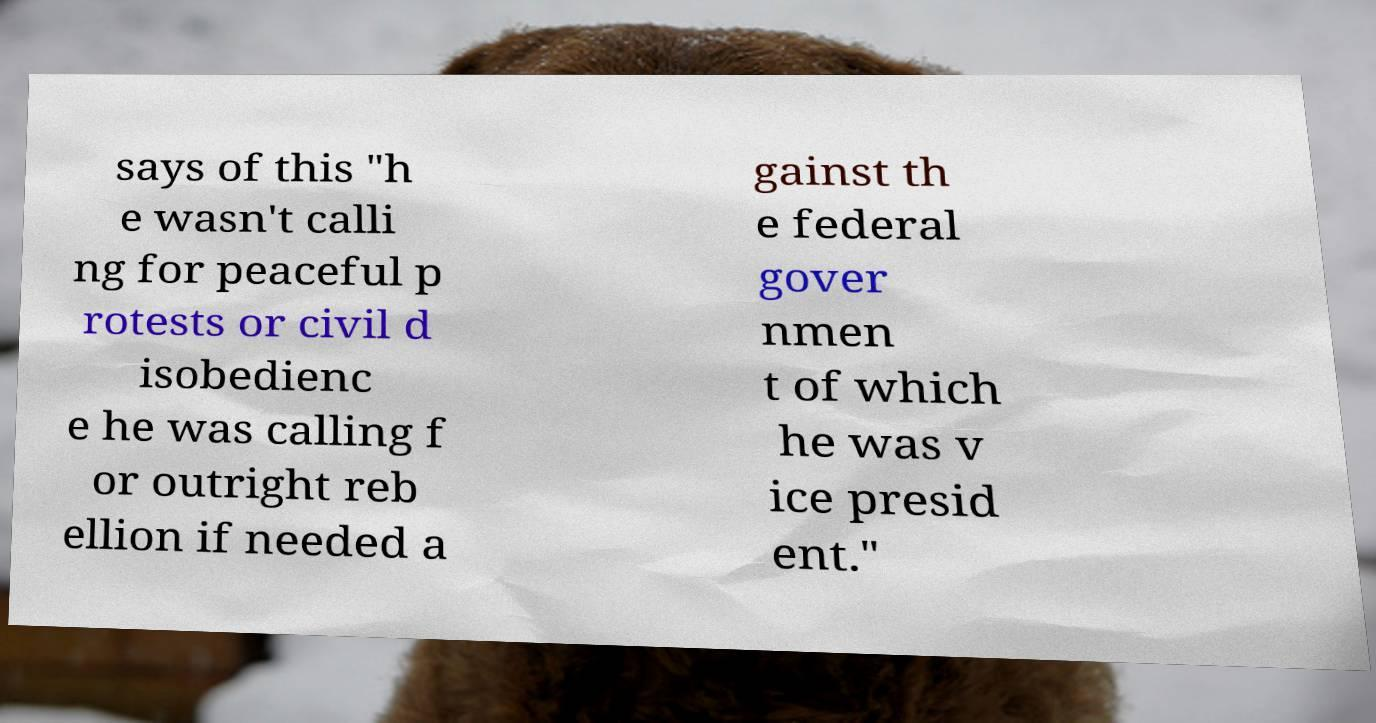I need the written content from this picture converted into text. Can you do that? says of this "h e wasn't calli ng for peaceful p rotests or civil d isobedienc e he was calling f or outright reb ellion if needed a gainst th e federal gover nmen t of which he was v ice presid ent." 